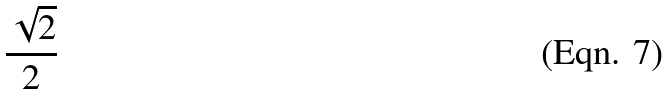<formula> <loc_0><loc_0><loc_500><loc_500>\frac { \sqrt { 2 } } { 2 }</formula> 